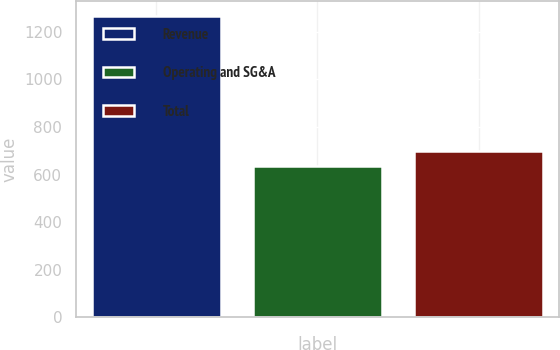Convert chart to OTSL. <chart><loc_0><loc_0><loc_500><loc_500><bar_chart><fcel>Revenue<fcel>Operating and SG&A<fcel>Total<nl><fcel>1268.3<fcel>636<fcel>699.23<nl></chart> 